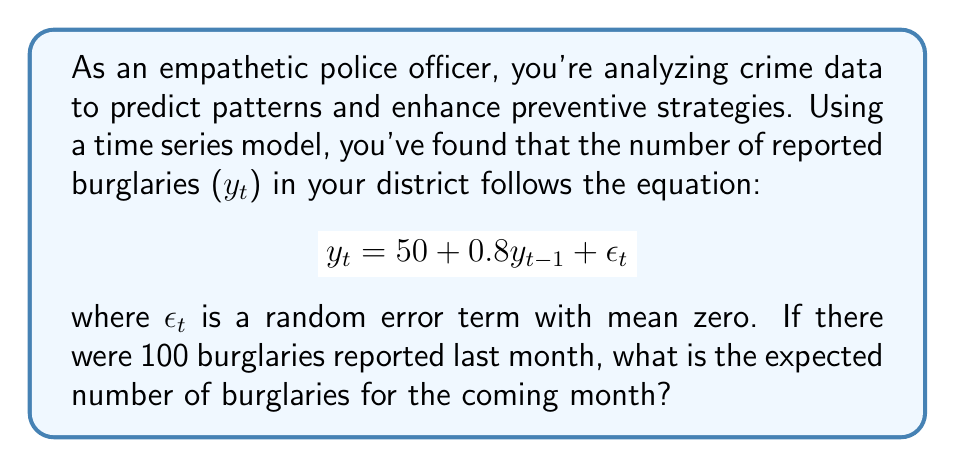Solve this math problem. To solve this problem, we'll follow these steps:

1. Identify the given information:
   - The time series model: $y_t = 50 + 0.8y_{t-1} + \epsilon_t$
   - Last month's burglaries: $y_{t-1} = 100$
   - $\epsilon_t$ has a mean of zero

2. Calculate the expected value of $y_t$:
   - The expected value of a random variable is denoted as $E[y_t]$
   - $E[\epsilon_t] = 0$ (given)
   - $E[y_t] = E[50 + 0.8y_{t-1} + \epsilon_t]$
   - $E[y_t] = 50 + 0.8E[y_{t-1}] + E[\epsilon_t]$
   - $E[y_t] = 50 + 0.8(100) + 0$

3. Compute the final result:
   $E[y_t] = 50 + 80 = 130$

Therefore, the expected number of burglaries for the coming month is 130.
Answer: 130 burglaries 